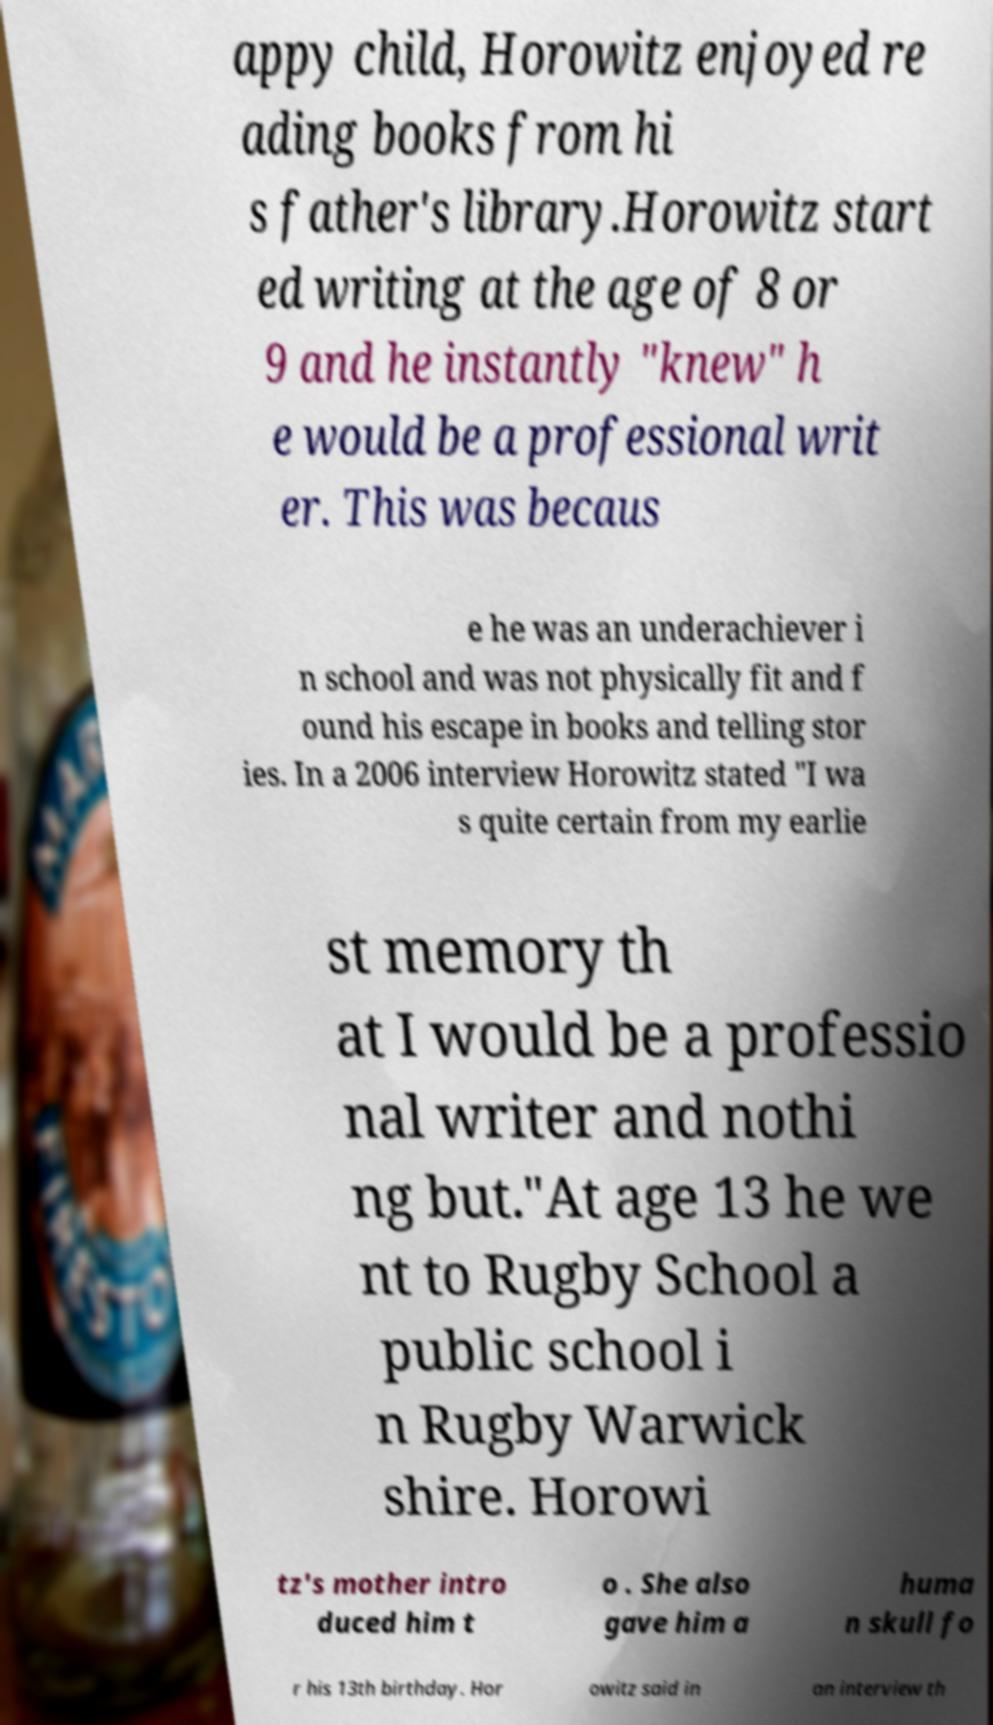Could you assist in decoding the text presented in this image and type it out clearly? appy child, Horowitz enjoyed re ading books from hi s father's library.Horowitz start ed writing at the age of 8 or 9 and he instantly "knew" h e would be a professional writ er. This was becaus e he was an underachiever i n school and was not physically fit and f ound his escape in books and telling stor ies. In a 2006 interview Horowitz stated "I wa s quite certain from my earlie st memory th at I would be a professio nal writer and nothi ng but."At age 13 he we nt to Rugby School a public school i n Rugby Warwick shire. Horowi tz's mother intro duced him t o . She also gave him a huma n skull fo r his 13th birthday. Hor owitz said in an interview th 